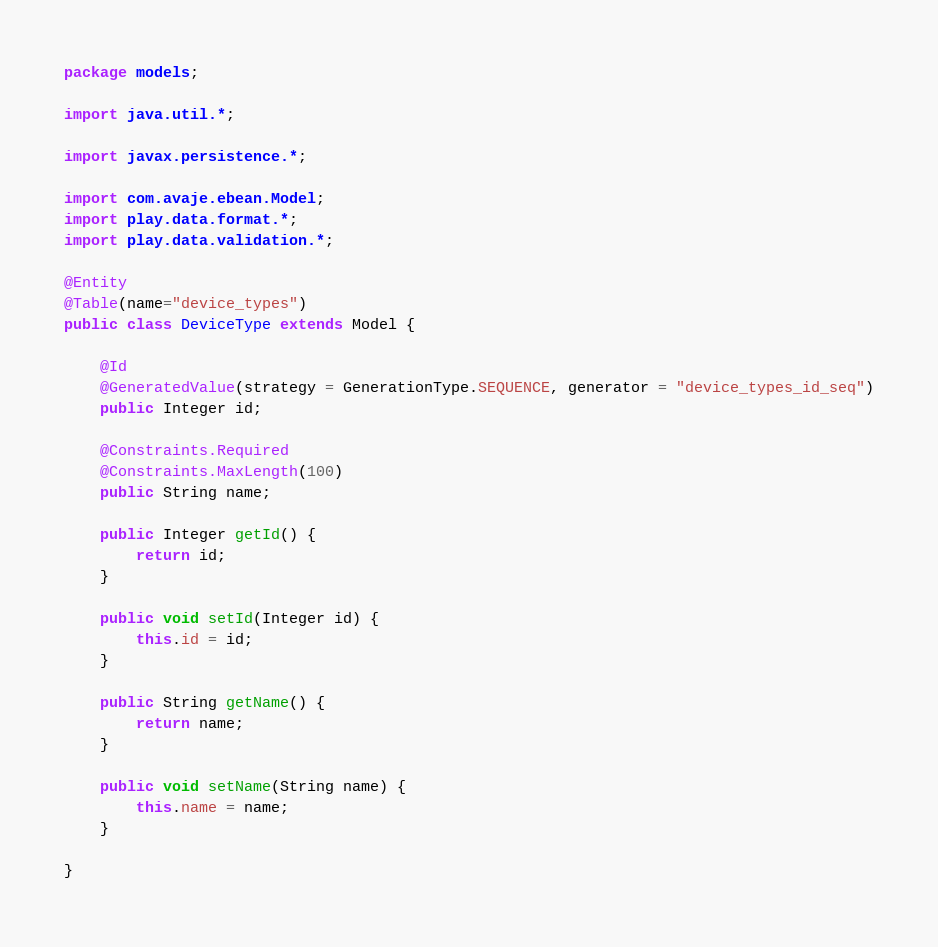Convert code to text. <code><loc_0><loc_0><loc_500><loc_500><_Java_>package models;

import java.util.*;

import javax.persistence.*;

import com.avaje.ebean.Model;
import play.data.format.*;
import play.data.validation.*;

@Entity
@Table(name="device_types")
public class DeviceType extends Model {

    @Id
    @GeneratedValue(strategy = GenerationType.SEQUENCE, generator = "device_types_id_seq")
    public Integer id;
  
    @Constraints.Required
    @Constraints.MaxLength(100)
    public String name;

	public Integer getId() {
		return id;
	}

	public void setId(Integer id) {
		this.id = id;
	}

	public String getName() {
		return name;
	}

	public void setName(String name) {
		this.name = name;
	}

}</code> 